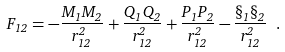Convert formula to latex. <formula><loc_0><loc_0><loc_500><loc_500>F _ { 1 2 } = - \frac { M _ { 1 } M _ { 2 } } { r _ { 1 2 } ^ { 2 } } + \frac { Q _ { 1 } Q _ { 2 } } { r _ { 1 2 } ^ { 2 } } + \frac { P _ { 1 } P _ { 2 } } { r _ { 1 2 } ^ { 2 } } - \frac { \S _ { 1 } \S _ { 2 } } { r _ { 1 2 } ^ { 2 } } \ .</formula> 